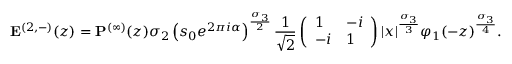Convert formula to latex. <formula><loc_0><loc_0><loc_500><loc_500>E ^ { ( 2 , - ) } ( z ) = P ^ { ( \infty ) } ( z ) \sigma _ { 2 } \left ( s _ { 0 } e ^ { 2 \pi i \alpha } \right ) ^ { \frac { \sigma _ { 3 } } { 2 } } \frac { 1 } { \sqrt { 2 } } \left ( \begin{array} { l l } { 1 } & { - i } \\ { - i } & { 1 } \end{array} \right ) | x | ^ { \frac { \sigma _ { 3 } } { 3 } } \varphi _ { 1 } ( - z ) ^ { \frac { \sigma _ { 3 } } { 4 } } .</formula> 